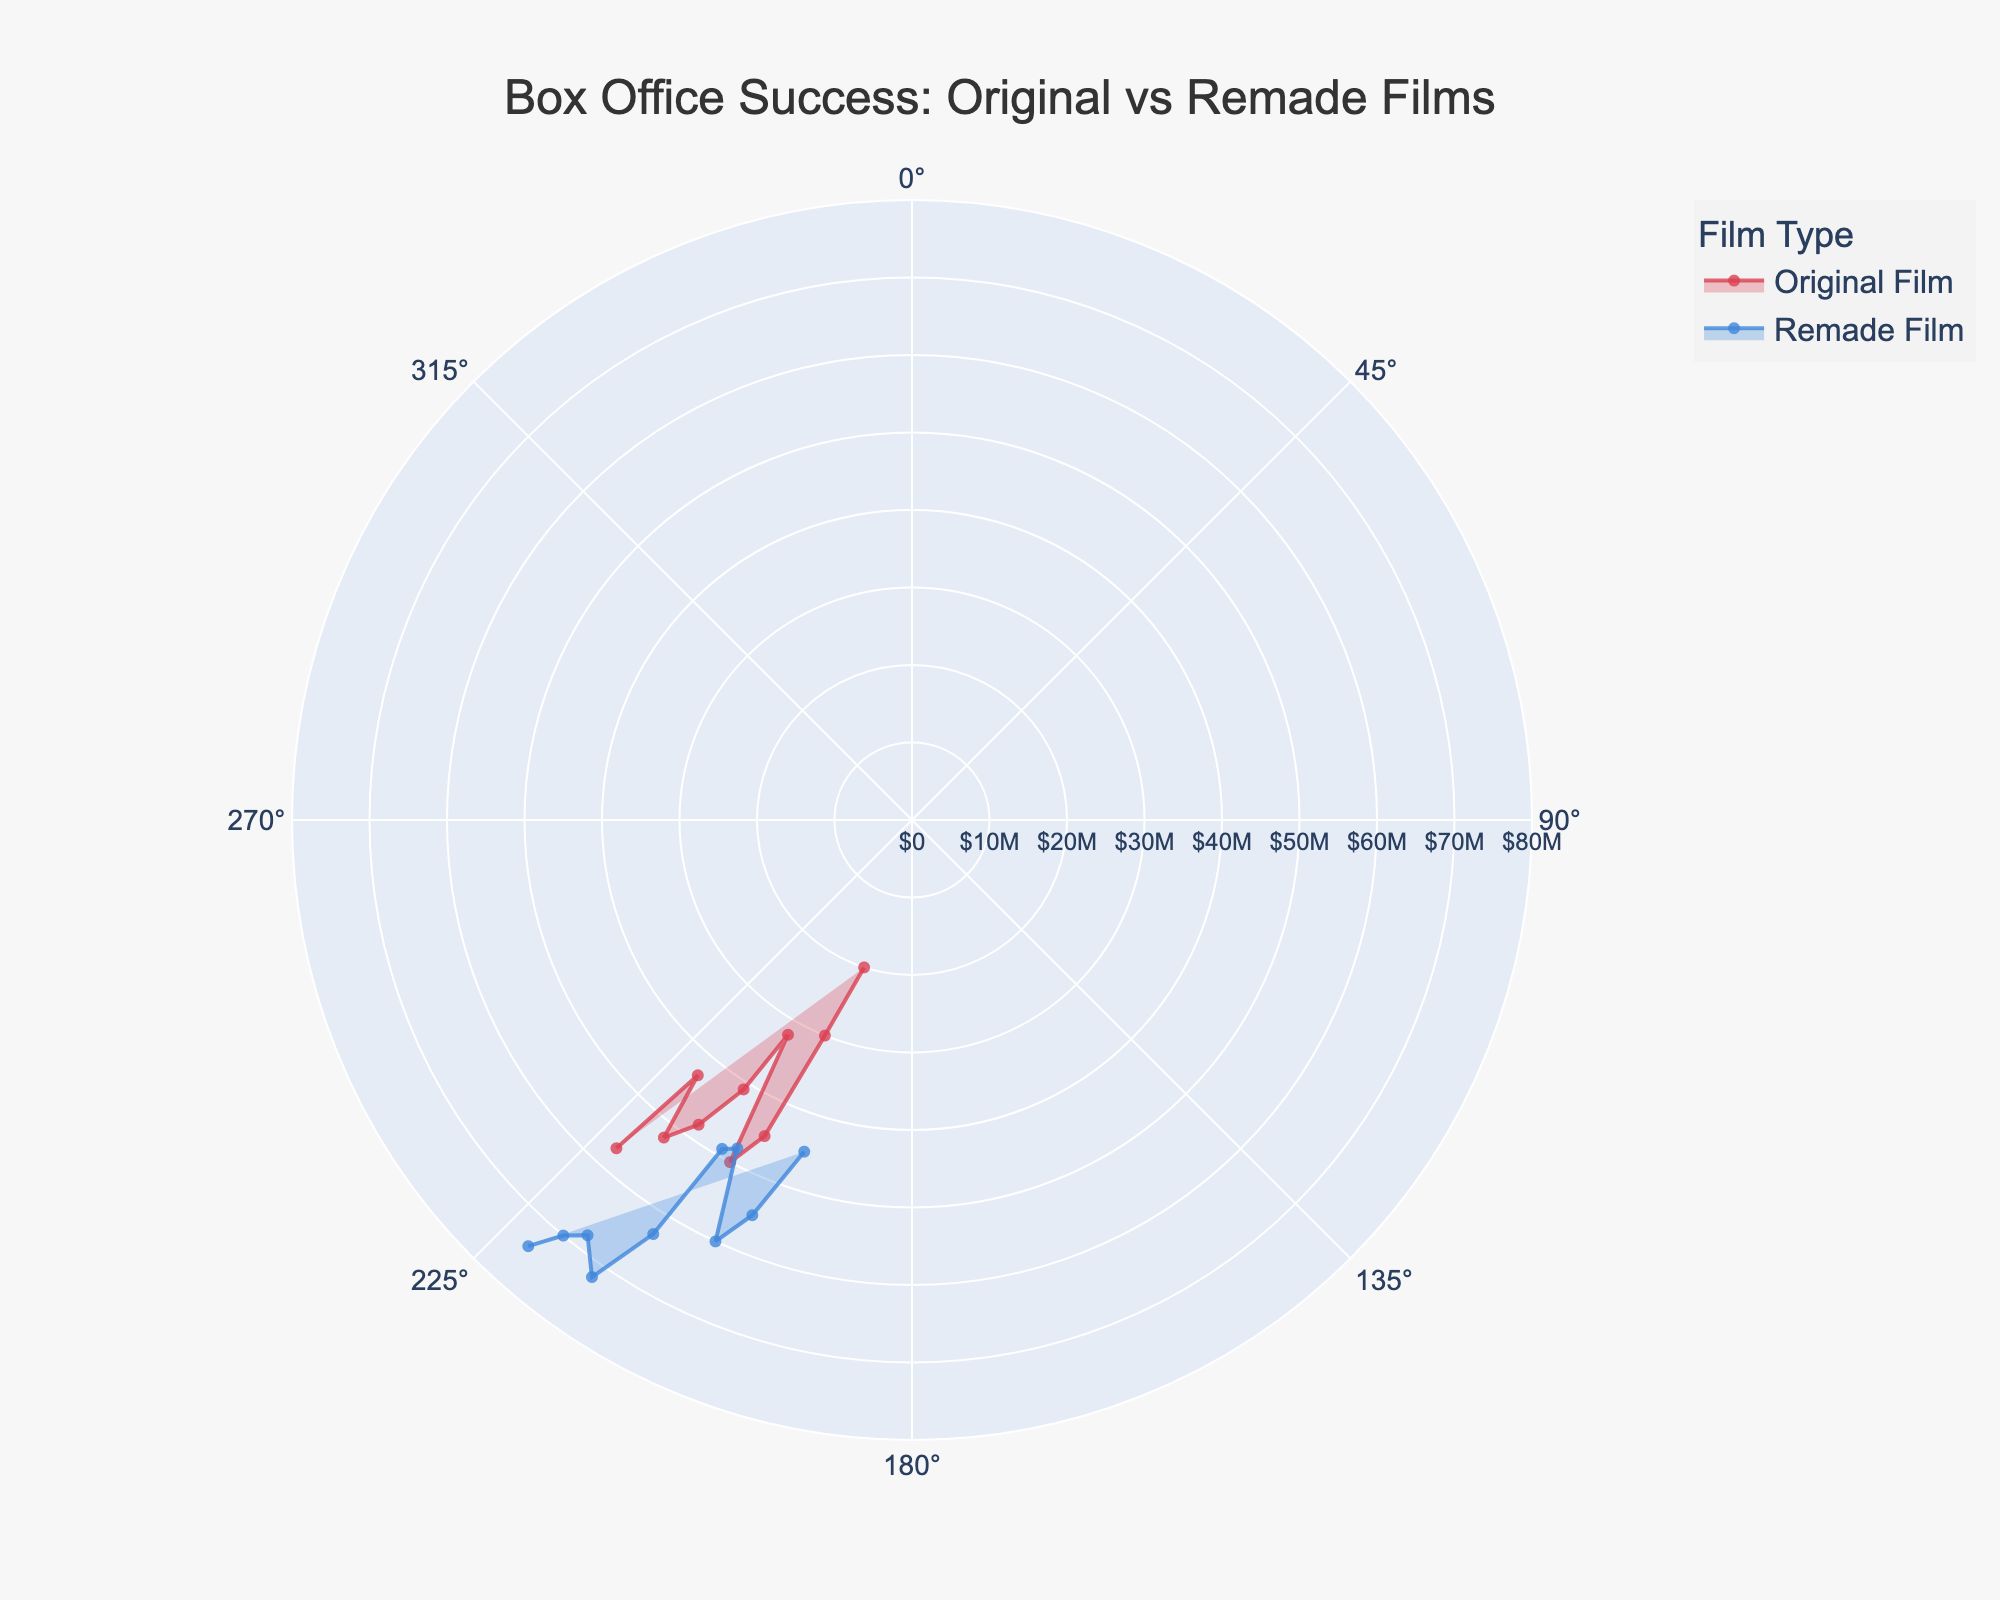What is the title of the chart? The title is displayed at the top of the chart in a larger font compared to other text elements.
Answer: Box Office Success: Original vs Remade Films How many data points are shown in the chart for each film type? Count the number of radial points for each film type, corresponding to the years from 1998 to 2022.
Answer: 10 Which year had the highest box office for original films? Identify the longest radial point for the 'Original Film' series and note the corresponding year on the angular axis.
Answer: 2022 How does the box office success of remade films in 2022 compare to that of original films in the same year? Compare the length of the radial points for original and remade films in 2022. The remade film's radial point is longer.
Answer: Remade films had higher box office success Which year had the lowest box office for original films? Identify the shortest radial point for the 'Original Film' series and note the corresponding year on the angular axis.
Answer: 1998 What is the average box office for original films from 1998 to 2022? Sum the box office values for original films from 1998 to 2022 and divide by the number of years (10). [(20000000 + 30000000 + 45000000 + 50000000 + 32000000 + 41000000 + 48000000 + 52000000 + 43000000 + 57000000) / 10]
Answer: 41800000 What is the total box office for remade films for the years 2018, 2020, and 2022 combined? Sum the box office values for remade films for 2018, 2020, and 2022. (68000000 + 70000000 + 74000000)
Answer: 212000000 In which year did remade films first surpass original films in box office success? Compare the radial points' lengths year-by-year and identify the first year where the remade film's radial point is longer than the original's.
Answer: 2002 How many years did remade films outperform original films overall? Count the years where the radial point for remade films is longer than the radial point for original films.
Answer: 7 years Which year saw the closest box office values between original and remade films? Find the year where the difference between the radial points for original and remade films is the smallest.
Answer: 2008 